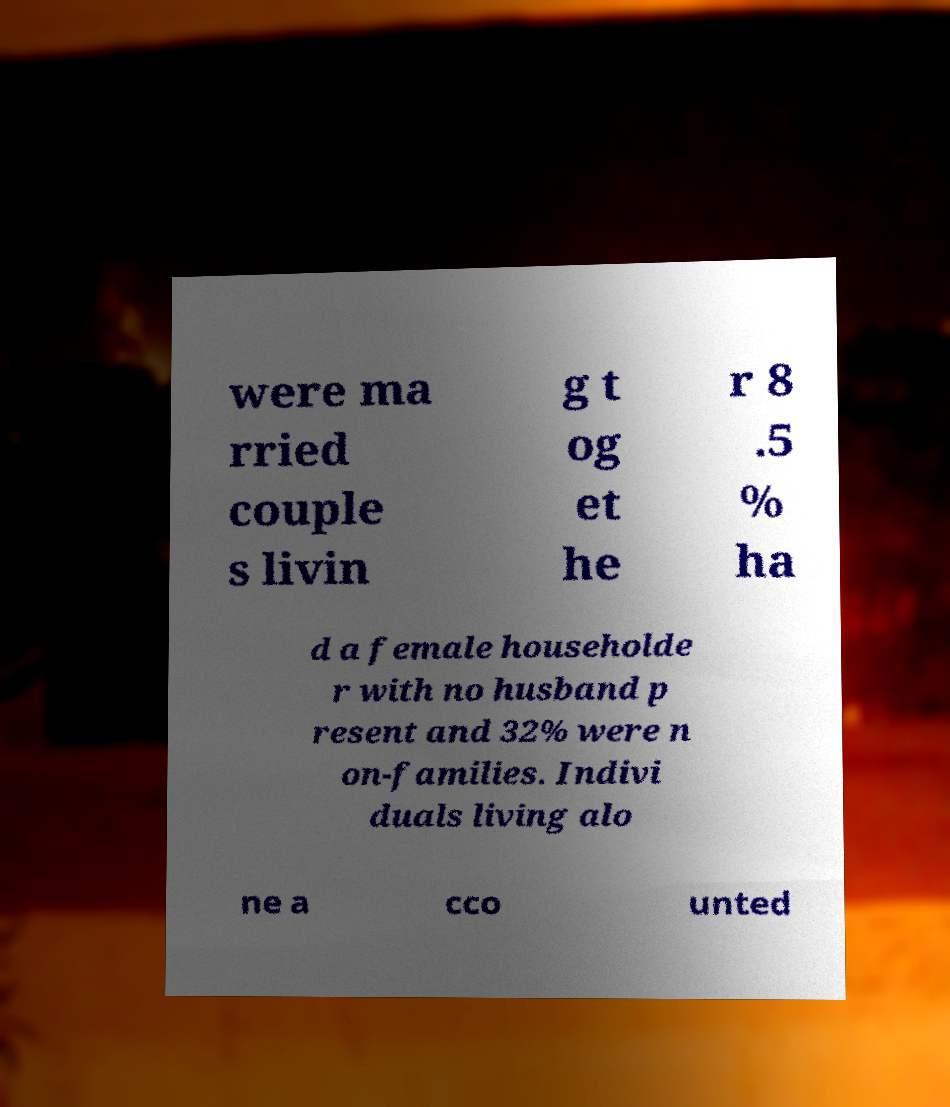I need the written content from this picture converted into text. Can you do that? were ma rried couple s livin g t og et he r 8 .5 % ha d a female householde r with no husband p resent and 32% were n on-families. Indivi duals living alo ne a cco unted 